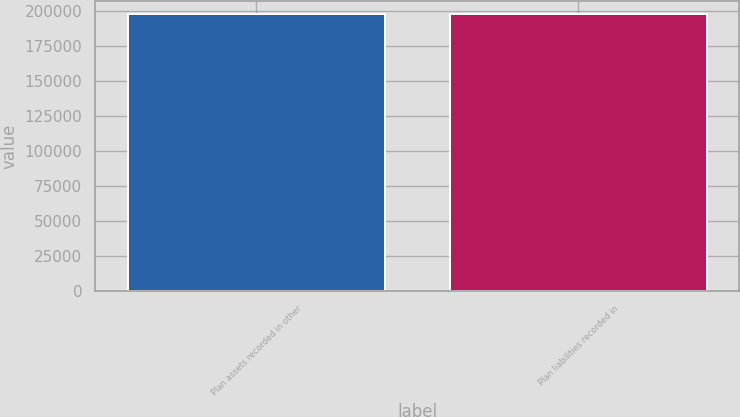Convert chart. <chart><loc_0><loc_0><loc_500><loc_500><bar_chart><fcel>Plan assets recorded in other<fcel>Plan liabilities recorded in<nl><fcel>197542<fcel>197542<nl></chart> 